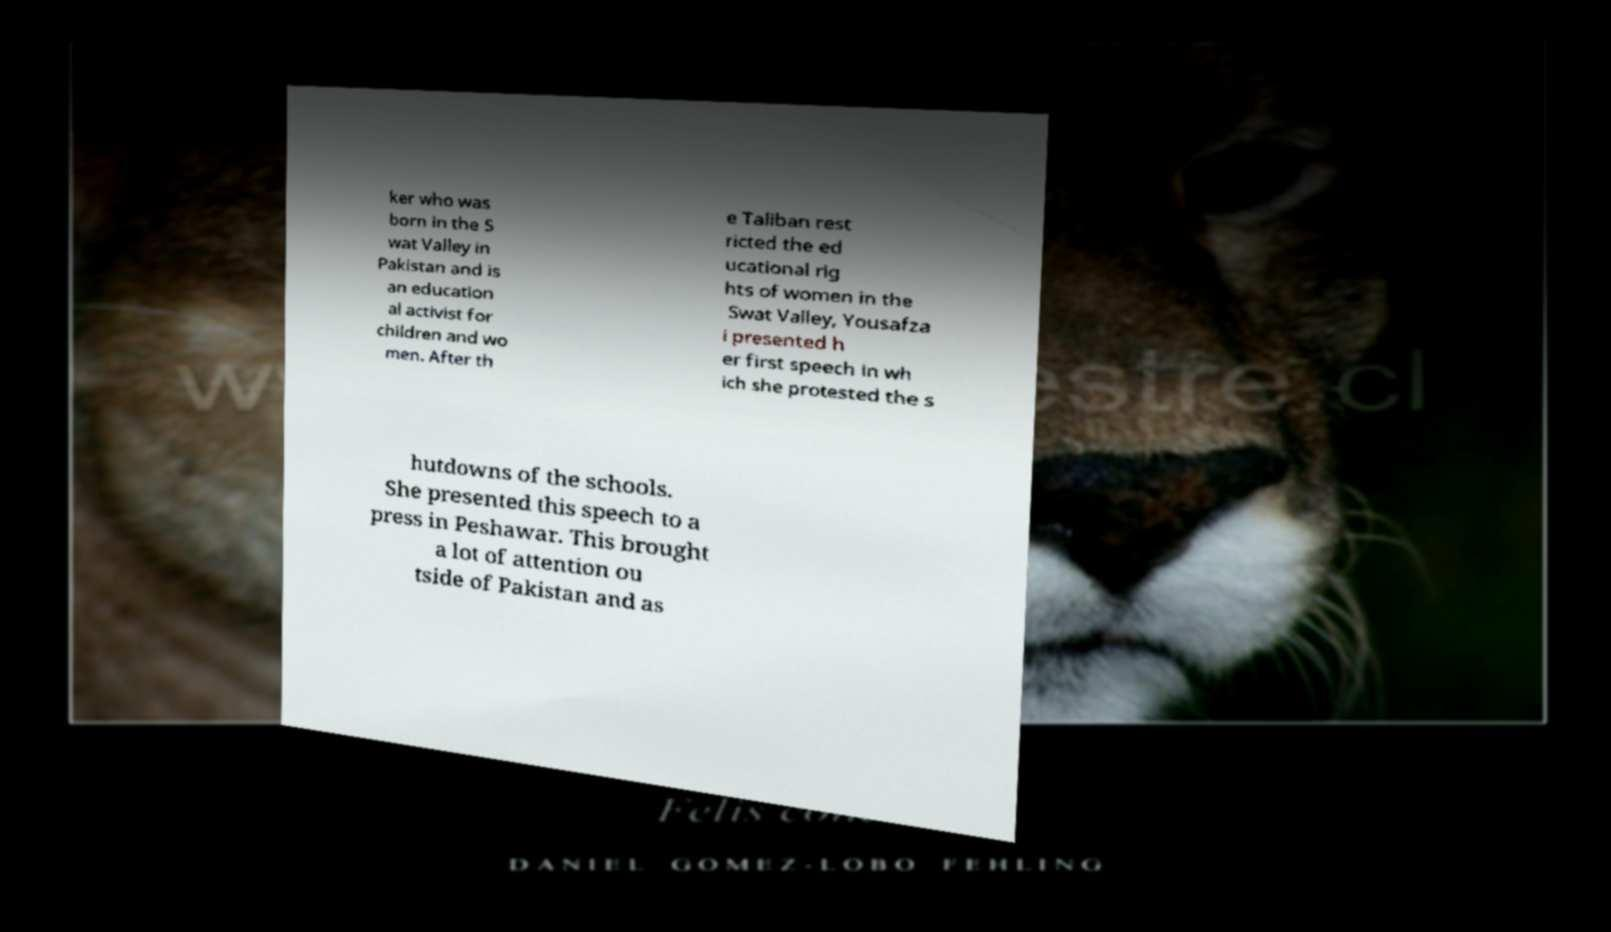Please identify and transcribe the text found in this image. ker who was born in the S wat Valley in Pakistan and is an education al activist for children and wo men. After th e Taliban rest ricted the ed ucational rig hts of women in the Swat Valley, Yousafza i presented h er first speech in wh ich she protested the s hutdowns of the schools. She presented this speech to a press in Peshawar. This brought a lot of attention ou tside of Pakistan and as 